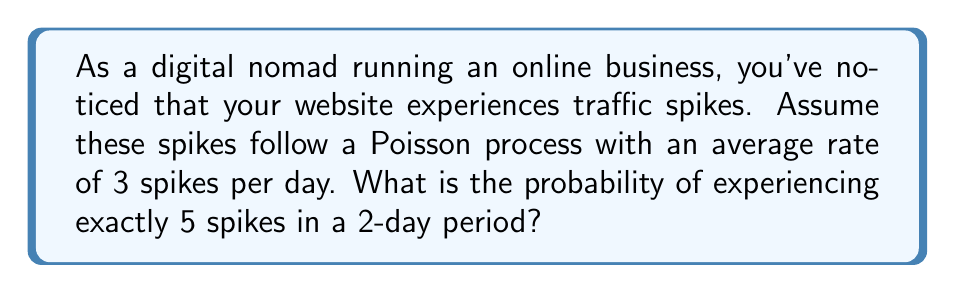Give your solution to this math problem. Let's approach this step-by-step:

1) The Poisson distribution is given by the formula:

   $$P(X = k) = \frac{e^{-\lambda} \lambda^k}{k!}$$

   where $\lambda$ is the average rate of events in the given time period, and $k$ is the number of events we're interested in.

2) We're given that the average rate is 3 spikes per day. For a 2-day period, we need to double this:

   $$\lambda = 3 \times 2 = 6$$

3) We want to find the probability of exactly 5 spikes, so $k = 5$.

4) Let's substitute these values into the Poisson formula:

   $$P(X = 5) = \frac{e^{-6} 6^5}{5!}$$

5) Now let's calculate this step-by-step:
   
   $$\begin{align}
   P(X = 5) &= \frac{e^{-6} \times 6^5}{5!} \\
   &= \frac{0.00247875 \times 7776}{120} \\
   &= \frac{19.27578}{120} \\
   &\approx 0.16063
   \end{align}$$

6) Convert to a percentage:

   $$0.16063 \times 100\% \approx 16.06\%$$
Answer: 16.06% 